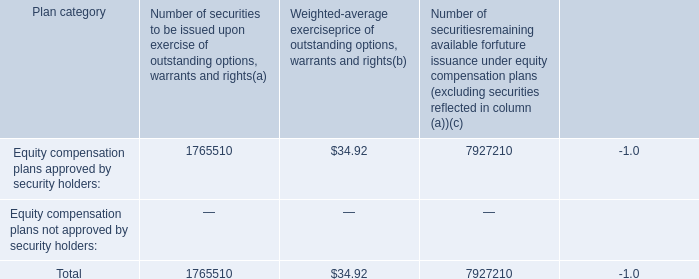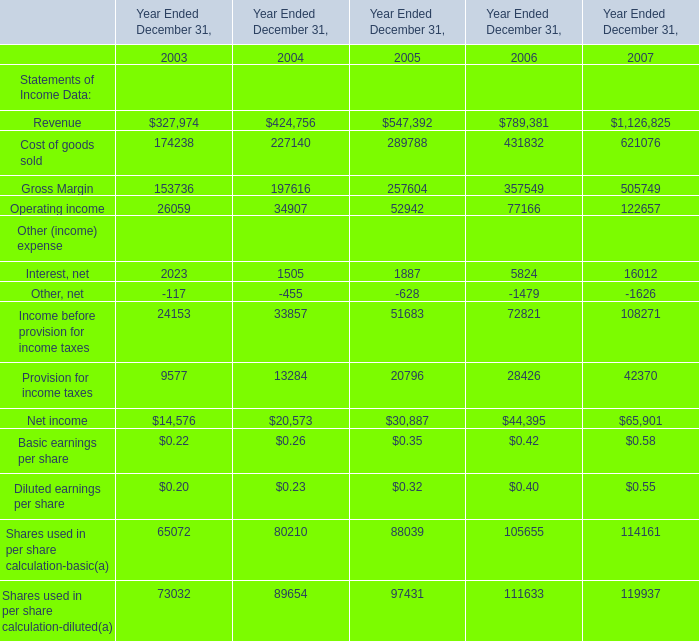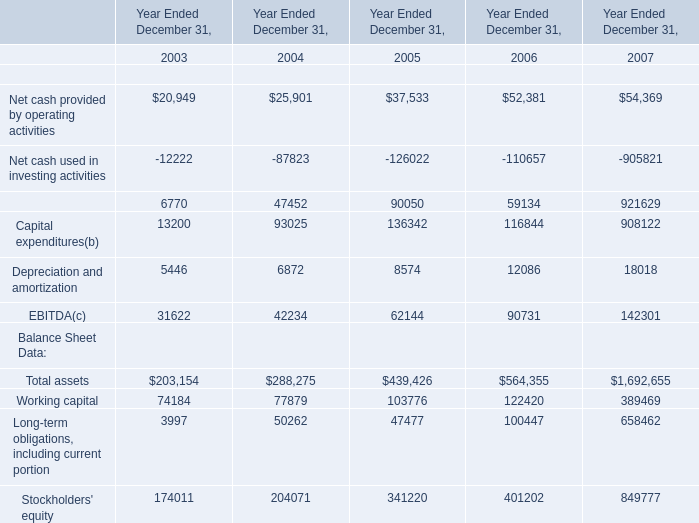What is the sum of the Cost of goods sold in the years where Revenue is positive? (in million) 
Computations: ((((174238 + 227140) + 289788) + 431832) + 621076)
Answer: 1744074.0. 